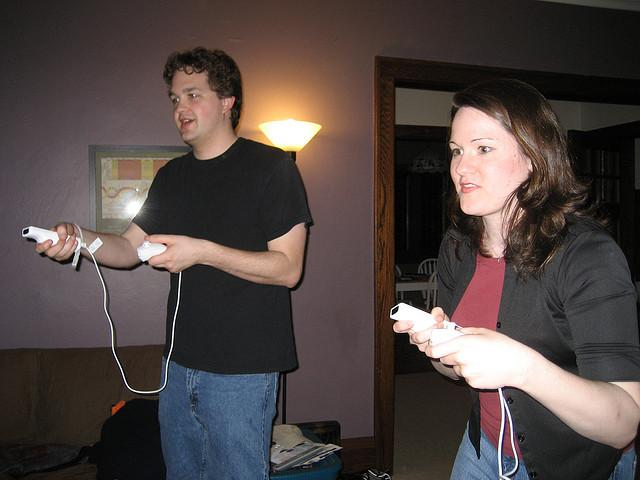What video game system are they playing? Please explain your reasoning. wii. The video game system is the nintendo wii. 